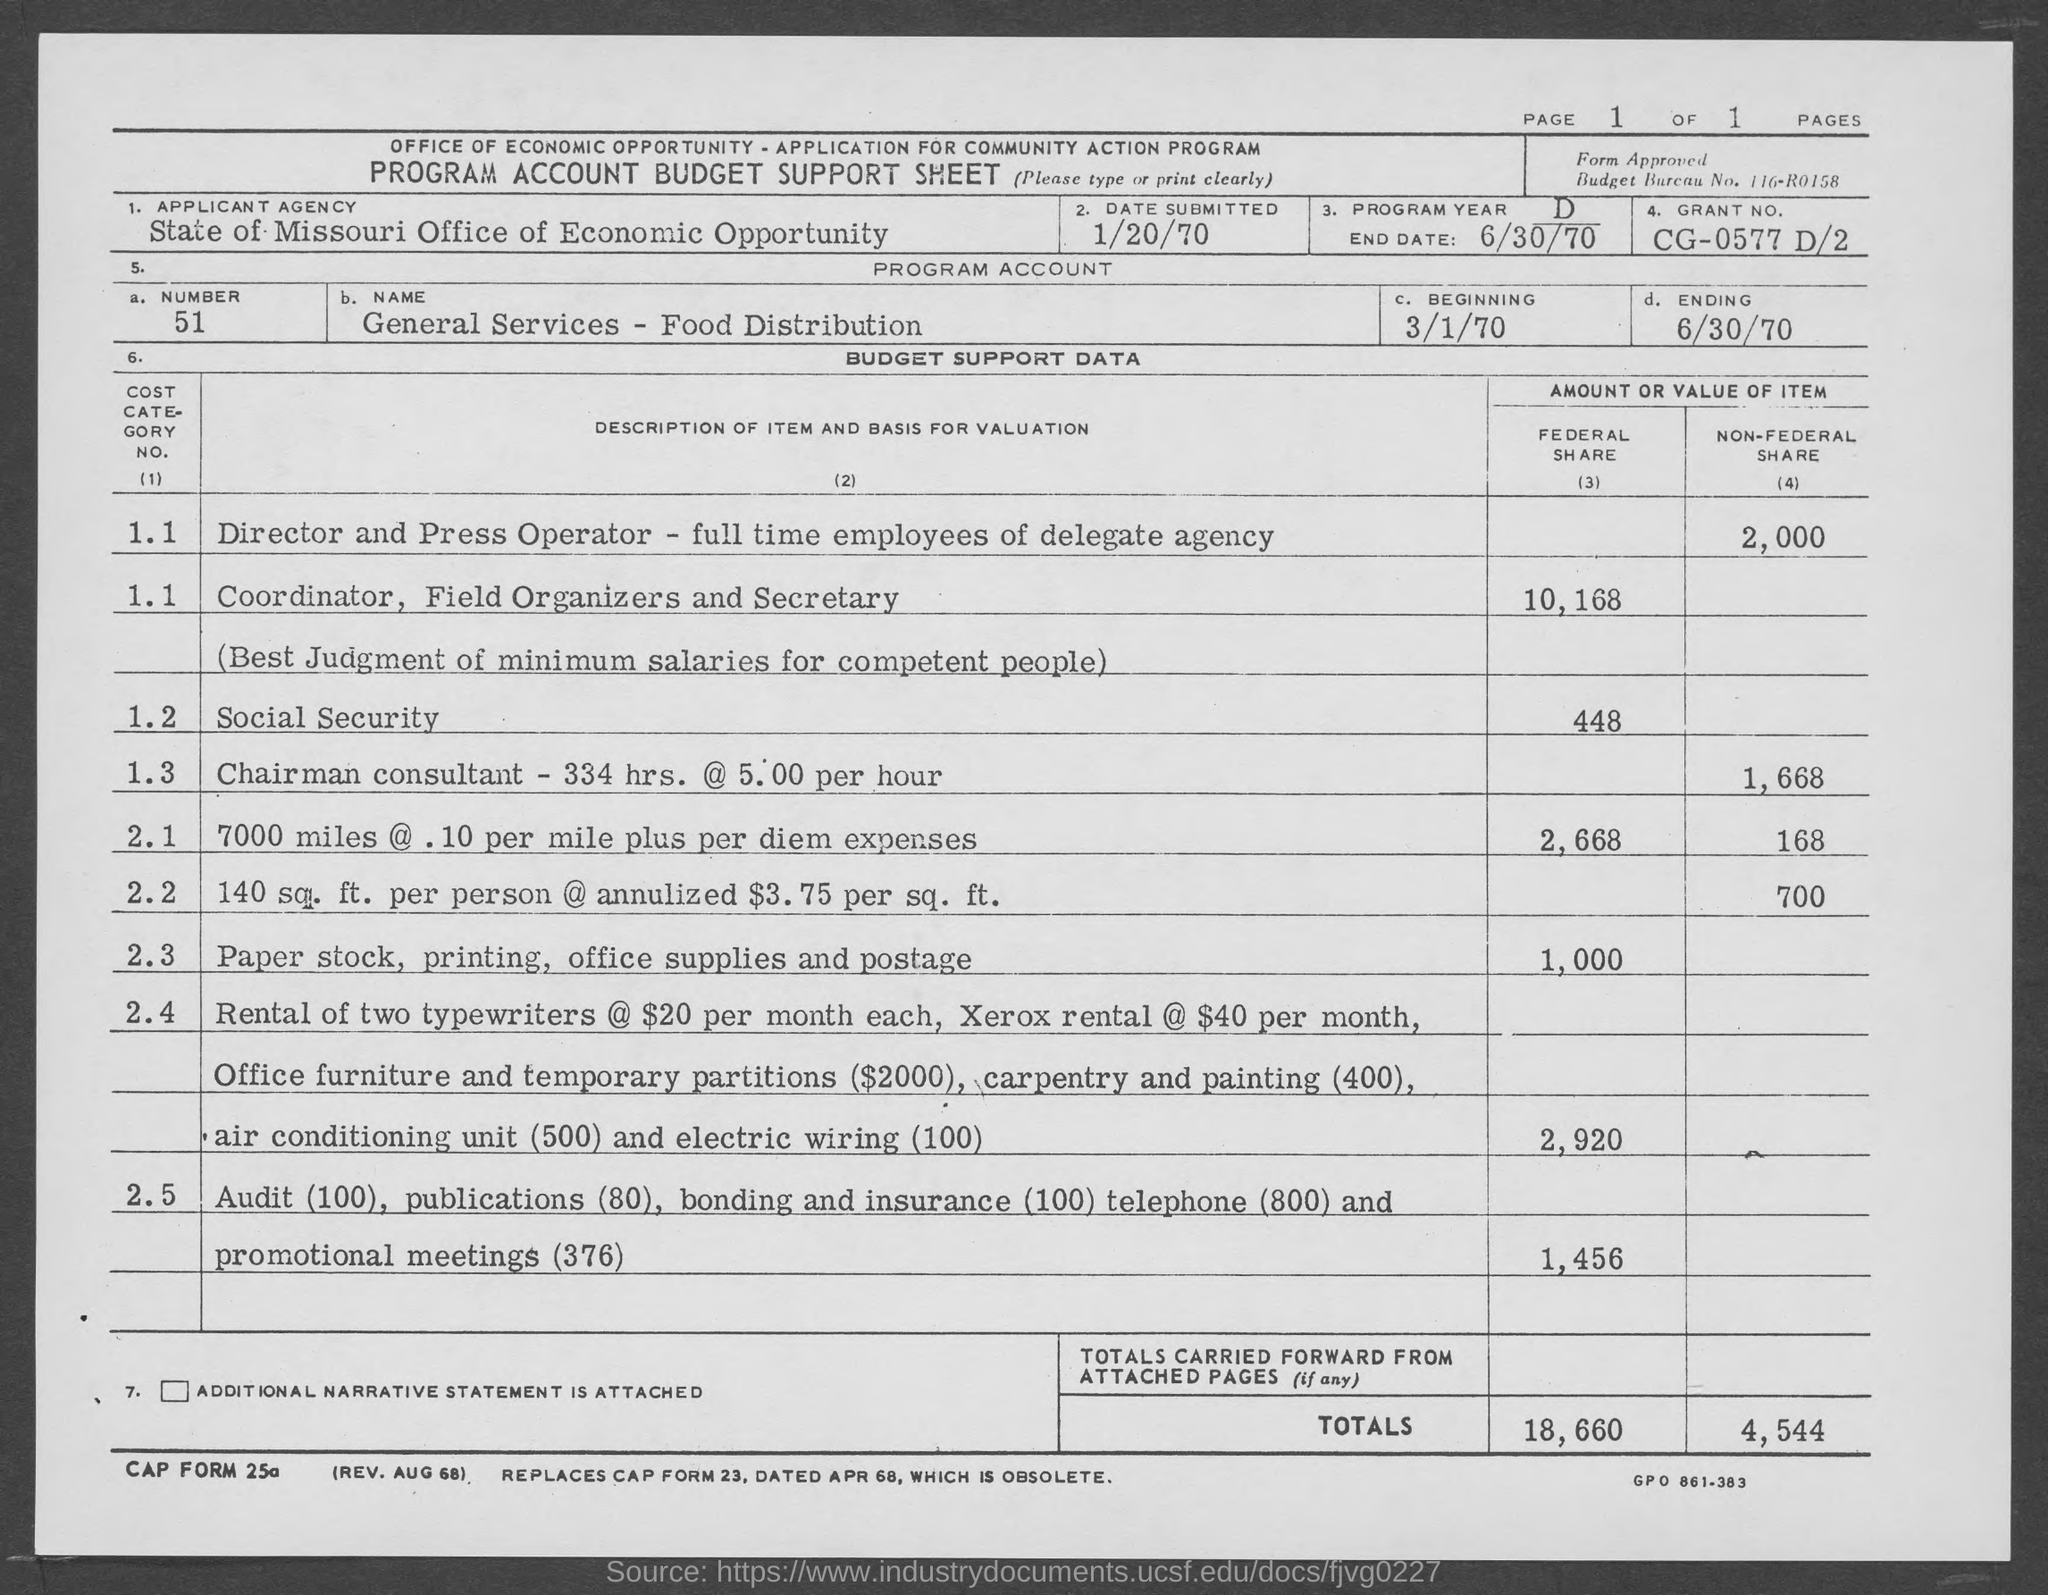What is the Applicant Agency?
Your answer should be compact. State of Missouri Office of Economic Opportunity. What is the Number?
Ensure brevity in your answer.  51. What is the Name?
Give a very brief answer. General Services - Food Distribution. What is the date submitted?
Offer a terse response. 1/20/70. What is the end date?
Provide a short and direct response. 6/30/70. What is the Grant No.?
Offer a terse response. CG-0577 D/2. What is the page number?
Make the answer very short. 1. 